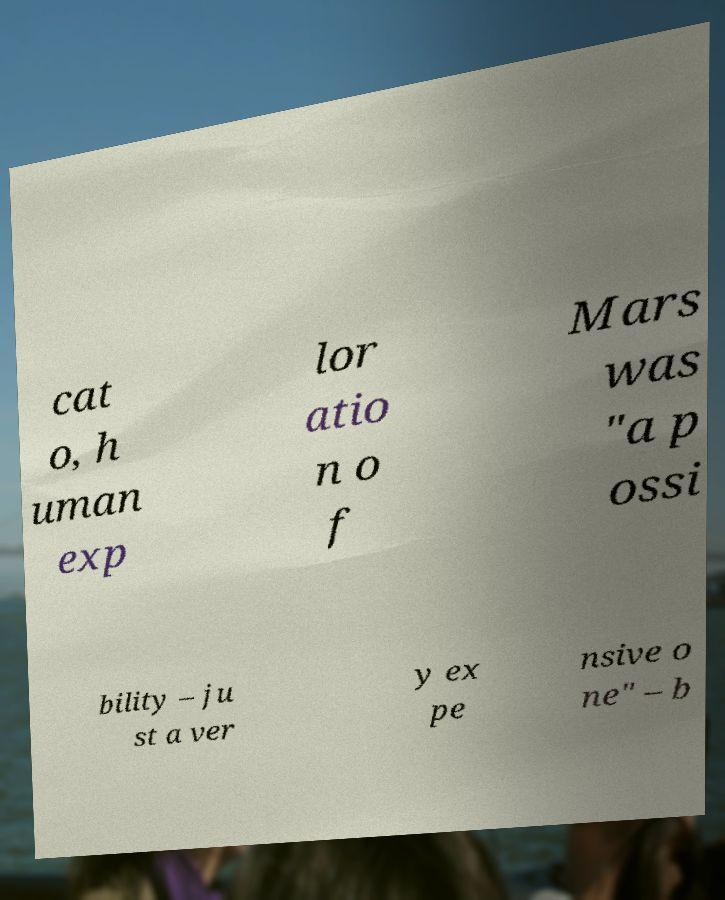Please read and relay the text visible in this image. What does it say? cat o, h uman exp lor atio n o f Mars was "a p ossi bility – ju st a ver y ex pe nsive o ne" – b 